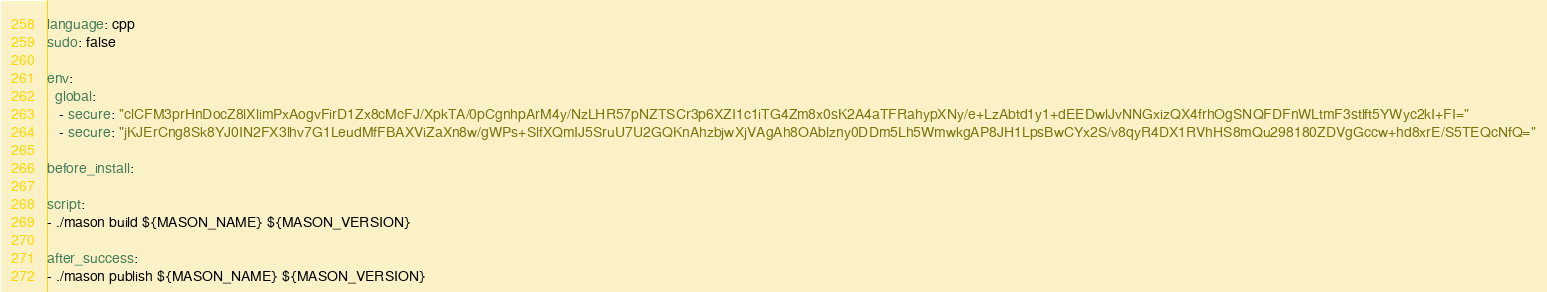Convert code to text. <code><loc_0><loc_0><loc_500><loc_500><_YAML_>language: cpp
sudo: false

env:
  global:
   - secure: "clCFM3prHnDocZ8lXlimPxAogvFirD1Zx8cMcFJ/XpkTA/0pCgnhpArM4y/NzLHR57pNZTSCr3p6XZI1c1iTG4Zm8x0sK2A4aTFRahypXNy/e+LzAbtd1y1+dEEDwlJvNNGxizQX4frhOgSNQFDFnWLtmF3stlft5YWyc2kI+FI="
   - secure: "jKJErCng8Sk8YJ0IN2FX3lhv7G1LeudMfFBAXViZaXn8w/gWPs+SlfXQmIJ5SruU7U2GQKnAhzbjwXjVAgAh8OAblzny0DDm5Lh5WmwkgAP8JH1LpsBwCYx2S/v8qyR4DX1RVhHS8mQu298180ZDVgGccw+hd8xrE/S5TEQcNfQ="

before_install:

script:
- ./mason build ${MASON_NAME} ${MASON_VERSION}

after_success:
- ./mason publish ${MASON_NAME} ${MASON_VERSION}</code> 